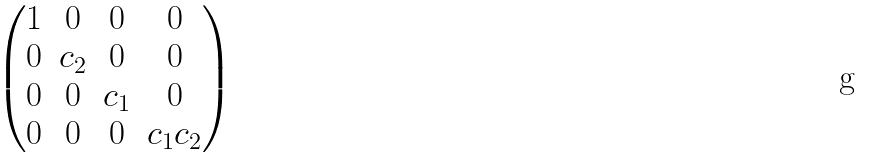<formula> <loc_0><loc_0><loc_500><loc_500>\begin{pmatrix} 1 & 0 & 0 & 0 \\ 0 & c _ { 2 } & 0 & 0 \\ 0 & 0 & c _ { 1 } & 0 \\ 0 & 0 & 0 & c _ { 1 } c _ { 2 } \end{pmatrix}</formula> 